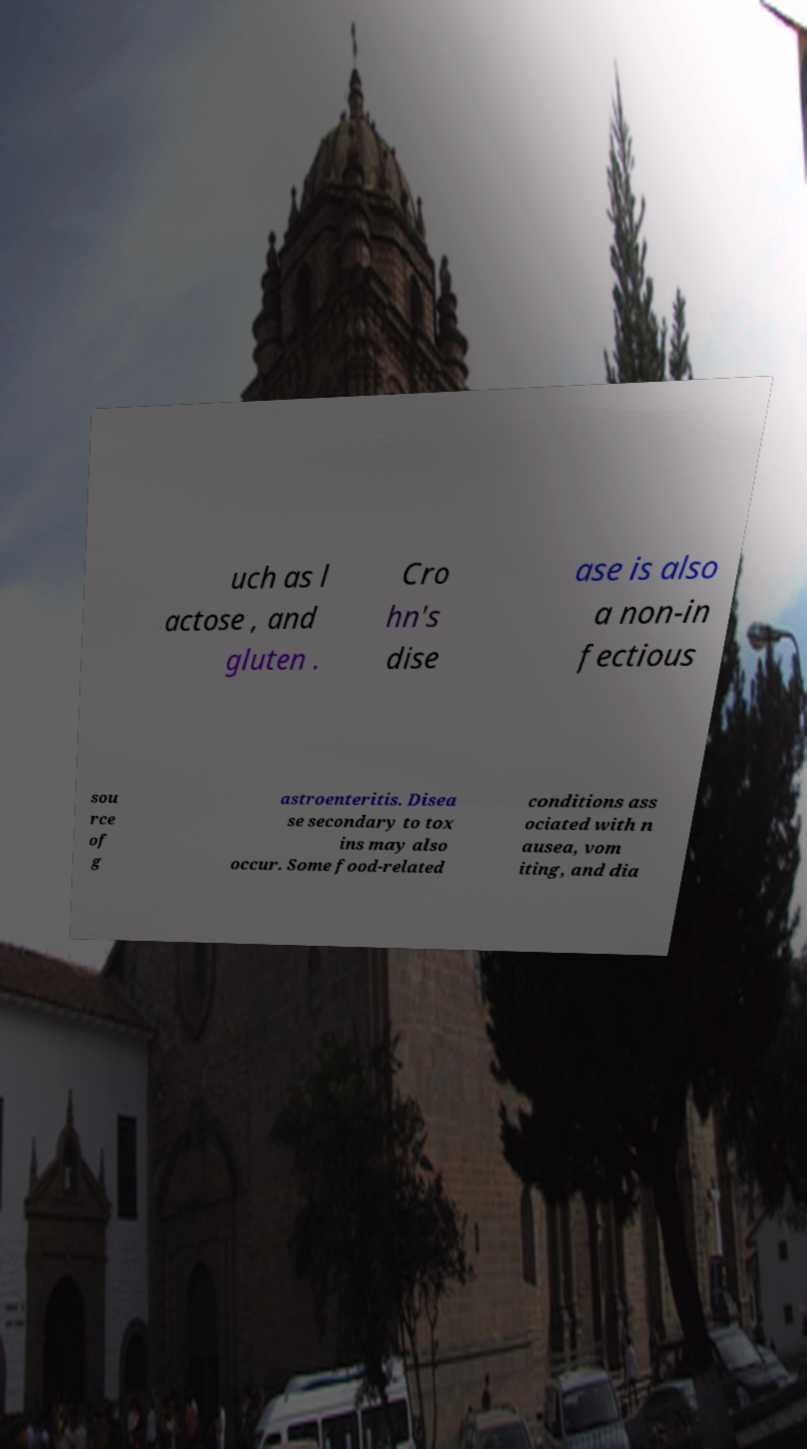Could you extract and type out the text from this image? uch as l actose , and gluten . Cro hn's dise ase is also a non-in fectious sou rce of g astroenteritis. Disea se secondary to tox ins may also occur. Some food-related conditions ass ociated with n ausea, vom iting, and dia 